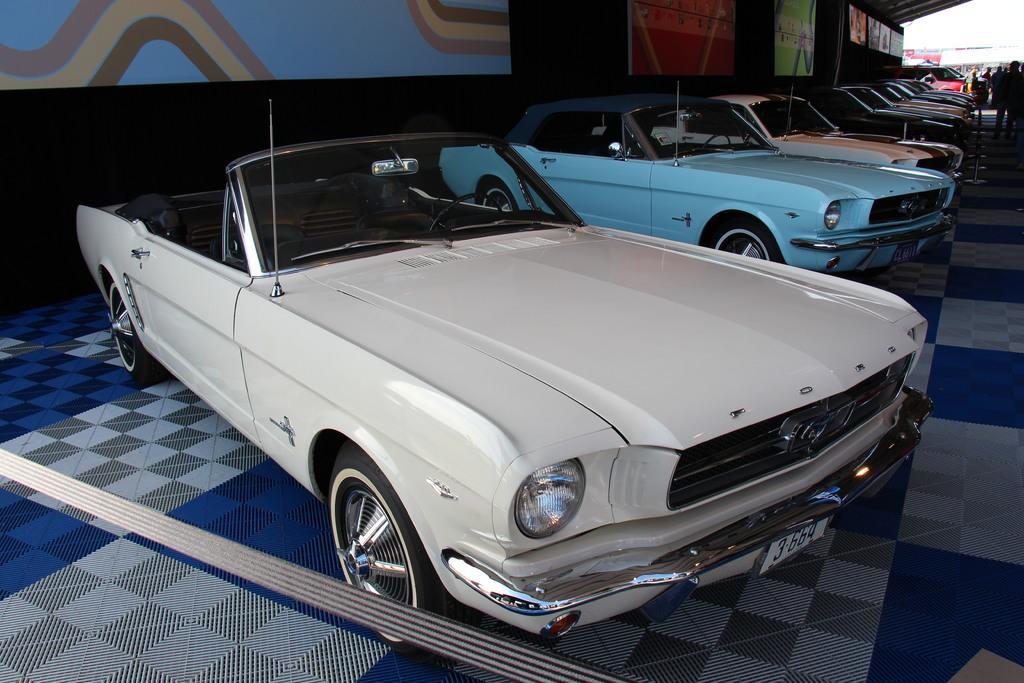Could you give a brief overview of what you see in this image? There are cars on the floor. Here we can see boards and few persons. In the background we can see sky. 